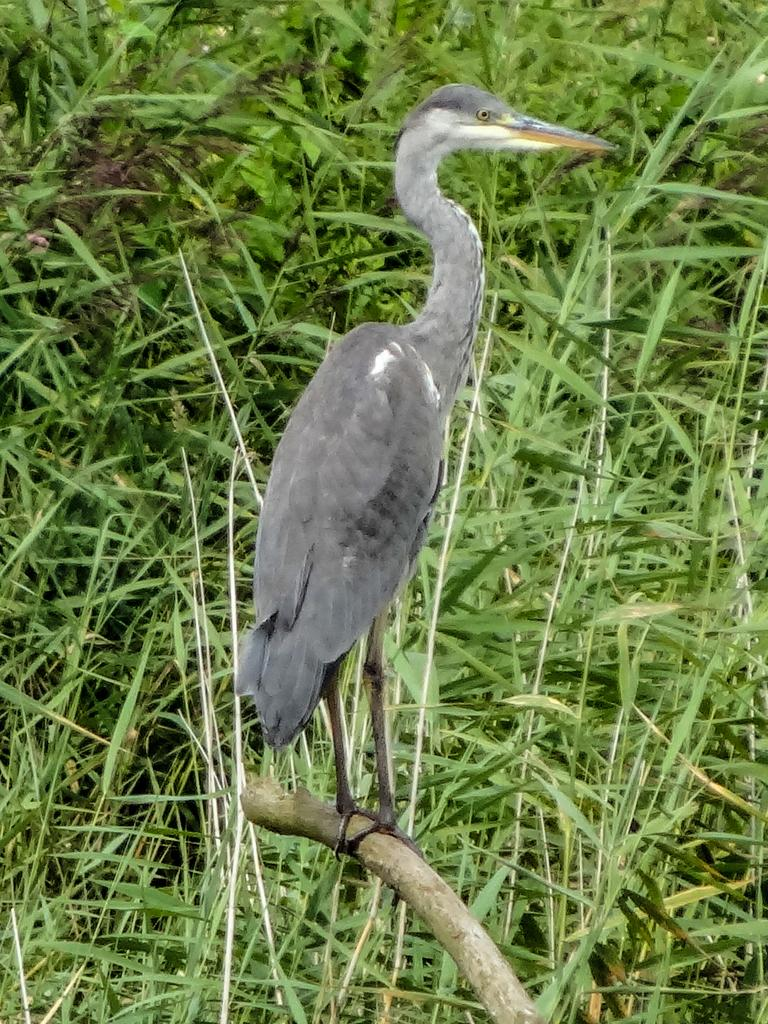What type of animal is in the image? There is a bird in the image. Where is the bird located? The bird is standing on the stem of a tree. What can be seen in the background of the image? There are leaves visible in the background of the image. What type of comb is the bird using to groom itself in the image? There is no comb present in the image, and the bird is not grooming itself. 